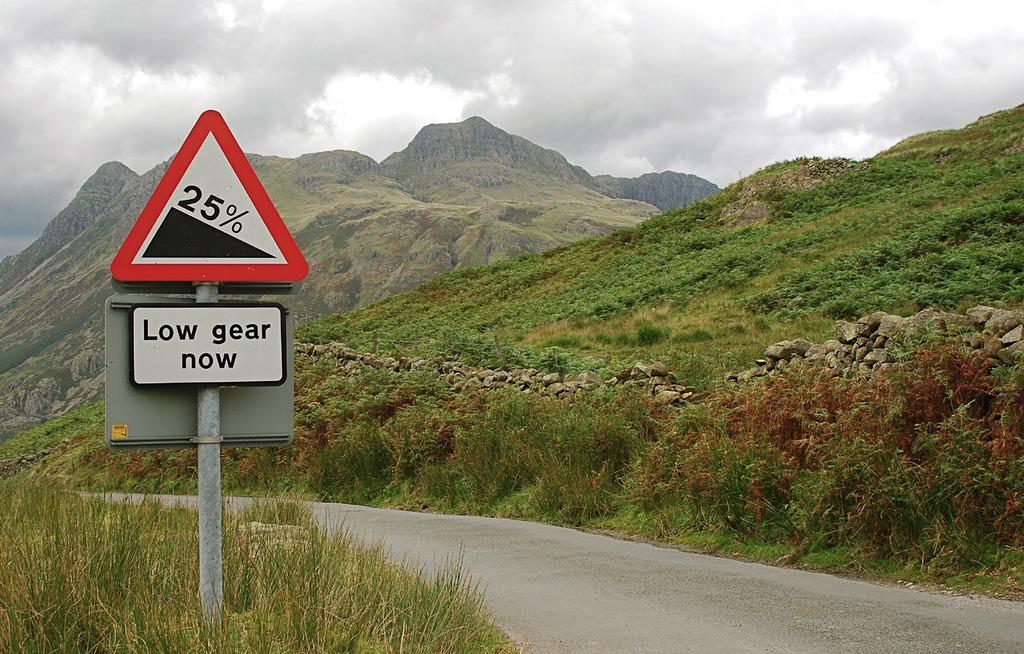Provide a one-sentence caption for the provided image. A beautiful mountain top behind green grass, beside a sign reading Low gear now. 